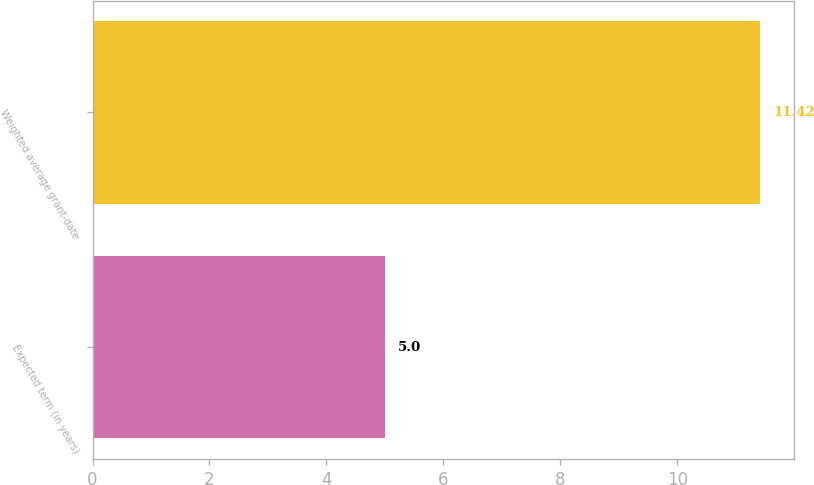Convert chart. <chart><loc_0><loc_0><loc_500><loc_500><bar_chart><fcel>Expected term (in years)<fcel>Weighted average grant-date<nl><fcel>5<fcel>11.42<nl></chart> 